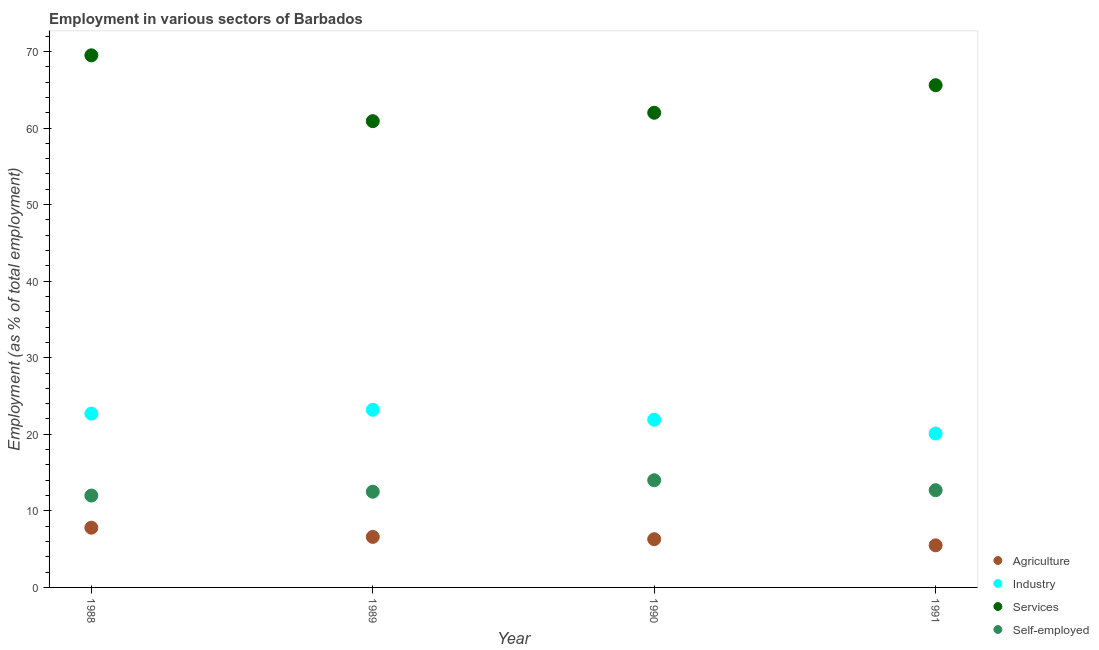How many different coloured dotlines are there?
Offer a very short reply. 4. What is the percentage of workers in services in 1991?
Make the answer very short. 65.6. Across all years, what is the maximum percentage of workers in industry?
Give a very brief answer. 23.2. Across all years, what is the minimum percentage of workers in services?
Make the answer very short. 60.9. In which year was the percentage of workers in industry maximum?
Your answer should be very brief. 1989. In which year was the percentage of self employed workers minimum?
Make the answer very short. 1988. What is the total percentage of workers in industry in the graph?
Give a very brief answer. 87.9. What is the difference between the percentage of workers in agriculture in 1990 and that in 1991?
Make the answer very short. 0.8. What is the difference between the percentage of self employed workers in 1988 and the percentage of workers in agriculture in 1990?
Your answer should be very brief. 5.7. What is the average percentage of workers in services per year?
Offer a very short reply. 64.5. In the year 1990, what is the difference between the percentage of workers in agriculture and percentage of self employed workers?
Your answer should be compact. -7.7. In how many years, is the percentage of self employed workers greater than 68 %?
Your answer should be very brief. 0. What is the ratio of the percentage of self employed workers in 1989 to that in 1990?
Keep it short and to the point. 0.89. Is the percentage of workers in agriculture in 1988 less than that in 1991?
Your answer should be very brief. No. Is the difference between the percentage of self employed workers in 1989 and 1990 greater than the difference between the percentage of workers in services in 1989 and 1990?
Your answer should be very brief. No. What is the difference between the highest and the second highest percentage of workers in agriculture?
Offer a terse response. 1.2. Is it the case that in every year, the sum of the percentage of workers in agriculture and percentage of workers in services is greater than the sum of percentage of workers in industry and percentage of self employed workers?
Provide a short and direct response. No. What is the difference between two consecutive major ticks on the Y-axis?
Provide a succinct answer. 10. Does the graph contain any zero values?
Ensure brevity in your answer.  No. Where does the legend appear in the graph?
Offer a terse response. Bottom right. How are the legend labels stacked?
Ensure brevity in your answer.  Vertical. What is the title of the graph?
Provide a succinct answer. Employment in various sectors of Barbados. What is the label or title of the Y-axis?
Your response must be concise. Employment (as % of total employment). What is the Employment (as % of total employment) in Agriculture in 1988?
Make the answer very short. 7.8. What is the Employment (as % of total employment) in Industry in 1988?
Make the answer very short. 22.7. What is the Employment (as % of total employment) of Services in 1988?
Provide a succinct answer. 69.5. What is the Employment (as % of total employment) in Self-employed in 1988?
Offer a terse response. 12. What is the Employment (as % of total employment) in Agriculture in 1989?
Keep it short and to the point. 6.6. What is the Employment (as % of total employment) in Industry in 1989?
Provide a short and direct response. 23.2. What is the Employment (as % of total employment) in Services in 1989?
Your answer should be compact. 60.9. What is the Employment (as % of total employment) in Agriculture in 1990?
Provide a short and direct response. 6.3. What is the Employment (as % of total employment) in Industry in 1990?
Your answer should be compact. 21.9. What is the Employment (as % of total employment) in Services in 1990?
Ensure brevity in your answer.  62. What is the Employment (as % of total employment) in Self-employed in 1990?
Your response must be concise. 14. What is the Employment (as % of total employment) in Agriculture in 1991?
Offer a very short reply. 5.5. What is the Employment (as % of total employment) of Industry in 1991?
Offer a very short reply. 20.1. What is the Employment (as % of total employment) in Services in 1991?
Ensure brevity in your answer.  65.6. What is the Employment (as % of total employment) of Self-employed in 1991?
Make the answer very short. 12.7. Across all years, what is the maximum Employment (as % of total employment) in Agriculture?
Your response must be concise. 7.8. Across all years, what is the maximum Employment (as % of total employment) in Industry?
Make the answer very short. 23.2. Across all years, what is the maximum Employment (as % of total employment) in Services?
Provide a short and direct response. 69.5. Across all years, what is the minimum Employment (as % of total employment) of Industry?
Your response must be concise. 20.1. Across all years, what is the minimum Employment (as % of total employment) of Services?
Provide a succinct answer. 60.9. What is the total Employment (as % of total employment) in Agriculture in the graph?
Make the answer very short. 26.2. What is the total Employment (as % of total employment) in Industry in the graph?
Keep it short and to the point. 87.9. What is the total Employment (as % of total employment) of Services in the graph?
Ensure brevity in your answer.  258. What is the total Employment (as % of total employment) of Self-employed in the graph?
Your answer should be compact. 51.2. What is the difference between the Employment (as % of total employment) of Industry in 1988 and that in 1989?
Ensure brevity in your answer.  -0.5. What is the difference between the Employment (as % of total employment) in Services in 1988 and that in 1989?
Give a very brief answer. 8.6. What is the difference between the Employment (as % of total employment) in Self-employed in 1988 and that in 1989?
Ensure brevity in your answer.  -0.5. What is the difference between the Employment (as % of total employment) of Agriculture in 1988 and that in 1990?
Your response must be concise. 1.5. What is the difference between the Employment (as % of total employment) of Industry in 1988 and that in 1990?
Provide a short and direct response. 0.8. What is the difference between the Employment (as % of total employment) in Agriculture in 1988 and that in 1991?
Offer a very short reply. 2.3. What is the difference between the Employment (as % of total employment) of Agriculture in 1989 and that in 1990?
Ensure brevity in your answer.  0.3. What is the difference between the Employment (as % of total employment) in Industry in 1989 and that in 1990?
Offer a very short reply. 1.3. What is the difference between the Employment (as % of total employment) of Services in 1989 and that in 1990?
Offer a terse response. -1.1. What is the difference between the Employment (as % of total employment) of Self-employed in 1989 and that in 1990?
Provide a short and direct response. -1.5. What is the difference between the Employment (as % of total employment) in Agriculture in 1989 and that in 1991?
Your answer should be compact. 1.1. What is the difference between the Employment (as % of total employment) of Self-employed in 1989 and that in 1991?
Provide a short and direct response. -0.2. What is the difference between the Employment (as % of total employment) in Industry in 1990 and that in 1991?
Keep it short and to the point. 1.8. What is the difference between the Employment (as % of total employment) of Self-employed in 1990 and that in 1991?
Your answer should be very brief. 1.3. What is the difference between the Employment (as % of total employment) in Agriculture in 1988 and the Employment (as % of total employment) in Industry in 1989?
Offer a very short reply. -15.4. What is the difference between the Employment (as % of total employment) of Agriculture in 1988 and the Employment (as % of total employment) of Services in 1989?
Provide a short and direct response. -53.1. What is the difference between the Employment (as % of total employment) in Industry in 1988 and the Employment (as % of total employment) in Services in 1989?
Offer a terse response. -38.2. What is the difference between the Employment (as % of total employment) in Industry in 1988 and the Employment (as % of total employment) in Self-employed in 1989?
Your response must be concise. 10.2. What is the difference between the Employment (as % of total employment) of Services in 1988 and the Employment (as % of total employment) of Self-employed in 1989?
Provide a short and direct response. 57. What is the difference between the Employment (as % of total employment) in Agriculture in 1988 and the Employment (as % of total employment) in Industry in 1990?
Offer a terse response. -14.1. What is the difference between the Employment (as % of total employment) in Agriculture in 1988 and the Employment (as % of total employment) in Services in 1990?
Provide a succinct answer. -54.2. What is the difference between the Employment (as % of total employment) in Industry in 1988 and the Employment (as % of total employment) in Services in 1990?
Provide a short and direct response. -39.3. What is the difference between the Employment (as % of total employment) of Industry in 1988 and the Employment (as % of total employment) of Self-employed in 1990?
Provide a short and direct response. 8.7. What is the difference between the Employment (as % of total employment) of Services in 1988 and the Employment (as % of total employment) of Self-employed in 1990?
Your answer should be very brief. 55.5. What is the difference between the Employment (as % of total employment) in Agriculture in 1988 and the Employment (as % of total employment) in Industry in 1991?
Offer a very short reply. -12.3. What is the difference between the Employment (as % of total employment) of Agriculture in 1988 and the Employment (as % of total employment) of Services in 1991?
Provide a succinct answer. -57.8. What is the difference between the Employment (as % of total employment) in Agriculture in 1988 and the Employment (as % of total employment) in Self-employed in 1991?
Offer a very short reply. -4.9. What is the difference between the Employment (as % of total employment) in Industry in 1988 and the Employment (as % of total employment) in Services in 1991?
Your answer should be compact. -42.9. What is the difference between the Employment (as % of total employment) in Industry in 1988 and the Employment (as % of total employment) in Self-employed in 1991?
Offer a terse response. 10. What is the difference between the Employment (as % of total employment) in Services in 1988 and the Employment (as % of total employment) in Self-employed in 1991?
Provide a succinct answer. 56.8. What is the difference between the Employment (as % of total employment) in Agriculture in 1989 and the Employment (as % of total employment) in Industry in 1990?
Make the answer very short. -15.3. What is the difference between the Employment (as % of total employment) in Agriculture in 1989 and the Employment (as % of total employment) in Services in 1990?
Offer a very short reply. -55.4. What is the difference between the Employment (as % of total employment) in Agriculture in 1989 and the Employment (as % of total employment) in Self-employed in 1990?
Your answer should be very brief. -7.4. What is the difference between the Employment (as % of total employment) of Industry in 1989 and the Employment (as % of total employment) of Services in 1990?
Your answer should be very brief. -38.8. What is the difference between the Employment (as % of total employment) in Industry in 1989 and the Employment (as % of total employment) in Self-employed in 1990?
Make the answer very short. 9.2. What is the difference between the Employment (as % of total employment) of Services in 1989 and the Employment (as % of total employment) of Self-employed in 1990?
Offer a very short reply. 46.9. What is the difference between the Employment (as % of total employment) in Agriculture in 1989 and the Employment (as % of total employment) in Services in 1991?
Give a very brief answer. -59. What is the difference between the Employment (as % of total employment) in Agriculture in 1989 and the Employment (as % of total employment) in Self-employed in 1991?
Your answer should be very brief. -6.1. What is the difference between the Employment (as % of total employment) in Industry in 1989 and the Employment (as % of total employment) in Services in 1991?
Your answer should be very brief. -42.4. What is the difference between the Employment (as % of total employment) in Industry in 1989 and the Employment (as % of total employment) in Self-employed in 1991?
Ensure brevity in your answer.  10.5. What is the difference between the Employment (as % of total employment) in Services in 1989 and the Employment (as % of total employment) in Self-employed in 1991?
Offer a very short reply. 48.2. What is the difference between the Employment (as % of total employment) in Agriculture in 1990 and the Employment (as % of total employment) in Industry in 1991?
Provide a short and direct response. -13.8. What is the difference between the Employment (as % of total employment) of Agriculture in 1990 and the Employment (as % of total employment) of Services in 1991?
Make the answer very short. -59.3. What is the difference between the Employment (as % of total employment) of Agriculture in 1990 and the Employment (as % of total employment) of Self-employed in 1991?
Give a very brief answer. -6.4. What is the difference between the Employment (as % of total employment) of Industry in 1990 and the Employment (as % of total employment) of Services in 1991?
Your response must be concise. -43.7. What is the difference between the Employment (as % of total employment) in Services in 1990 and the Employment (as % of total employment) in Self-employed in 1991?
Offer a very short reply. 49.3. What is the average Employment (as % of total employment) of Agriculture per year?
Offer a very short reply. 6.55. What is the average Employment (as % of total employment) in Industry per year?
Make the answer very short. 21.98. What is the average Employment (as % of total employment) in Services per year?
Offer a very short reply. 64.5. In the year 1988, what is the difference between the Employment (as % of total employment) of Agriculture and Employment (as % of total employment) of Industry?
Your response must be concise. -14.9. In the year 1988, what is the difference between the Employment (as % of total employment) in Agriculture and Employment (as % of total employment) in Services?
Your response must be concise. -61.7. In the year 1988, what is the difference between the Employment (as % of total employment) in Agriculture and Employment (as % of total employment) in Self-employed?
Provide a succinct answer. -4.2. In the year 1988, what is the difference between the Employment (as % of total employment) of Industry and Employment (as % of total employment) of Services?
Offer a terse response. -46.8. In the year 1988, what is the difference between the Employment (as % of total employment) of Services and Employment (as % of total employment) of Self-employed?
Make the answer very short. 57.5. In the year 1989, what is the difference between the Employment (as % of total employment) in Agriculture and Employment (as % of total employment) in Industry?
Offer a terse response. -16.6. In the year 1989, what is the difference between the Employment (as % of total employment) of Agriculture and Employment (as % of total employment) of Services?
Provide a short and direct response. -54.3. In the year 1989, what is the difference between the Employment (as % of total employment) of Agriculture and Employment (as % of total employment) of Self-employed?
Offer a terse response. -5.9. In the year 1989, what is the difference between the Employment (as % of total employment) in Industry and Employment (as % of total employment) in Services?
Provide a succinct answer. -37.7. In the year 1989, what is the difference between the Employment (as % of total employment) in Services and Employment (as % of total employment) in Self-employed?
Your response must be concise. 48.4. In the year 1990, what is the difference between the Employment (as % of total employment) in Agriculture and Employment (as % of total employment) in Industry?
Offer a very short reply. -15.6. In the year 1990, what is the difference between the Employment (as % of total employment) of Agriculture and Employment (as % of total employment) of Services?
Ensure brevity in your answer.  -55.7. In the year 1990, what is the difference between the Employment (as % of total employment) of Industry and Employment (as % of total employment) of Services?
Your answer should be compact. -40.1. In the year 1991, what is the difference between the Employment (as % of total employment) of Agriculture and Employment (as % of total employment) of Industry?
Your answer should be compact. -14.6. In the year 1991, what is the difference between the Employment (as % of total employment) in Agriculture and Employment (as % of total employment) in Services?
Make the answer very short. -60.1. In the year 1991, what is the difference between the Employment (as % of total employment) of Agriculture and Employment (as % of total employment) of Self-employed?
Make the answer very short. -7.2. In the year 1991, what is the difference between the Employment (as % of total employment) in Industry and Employment (as % of total employment) in Services?
Ensure brevity in your answer.  -45.5. In the year 1991, what is the difference between the Employment (as % of total employment) of Industry and Employment (as % of total employment) of Self-employed?
Your answer should be compact. 7.4. In the year 1991, what is the difference between the Employment (as % of total employment) of Services and Employment (as % of total employment) of Self-employed?
Offer a terse response. 52.9. What is the ratio of the Employment (as % of total employment) in Agriculture in 1988 to that in 1989?
Your answer should be very brief. 1.18. What is the ratio of the Employment (as % of total employment) of Industry in 1988 to that in 1989?
Offer a very short reply. 0.98. What is the ratio of the Employment (as % of total employment) of Services in 1988 to that in 1989?
Make the answer very short. 1.14. What is the ratio of the Employment (as % of total employment) in Agriculture in 1988 to that in 1990?
Your answer should be compact. 1.24. What is the ratio of the Employment (as % of total employment) in Industry in 1988 to that in 1990?
Your answer should be very brief. 1.04. What is the ratio of the Employment (as % of total employment) of Services in 1988 to that in 1990?
Give a very brief answer. 1.12. What is the ratio of the Employment (as % of total employment) of Agriculture in 1988 to that in 1991?
Offer a terse response. 1.42. What is the ratio of the Employment (as % of total employment) in Industry in 1988 to that in 1991?
Make the answer very short. 1.13. What is the ratio of the Employment (as % of total employment) of Services in 1988 to that in 1991?
Your response must be concise. 1.06. What is the ratio of the Employment (as % of total employment) in Self-employed in 1988 to that in 1991?
Make the answer very short. 0.94. What is the ratio of the Employment (as % of total employment) of Agriculture in 1989 to that in 1990?
Give a very brief answer. 1.05. What is the ratio of the Employment (as % of total employment) of Industry in 1989 to that in 1990?
Your answer should be very brief. 1.06. What is the ratio of the Employment (as % of total employment) in Services in 1989 to that in 1990?
Your response must be concise. 0.98. What is the ratio of the Employment (as % of total employment) of Self-employed in 1989 to that in 1990?
Your answer should be compact. 0.89. What is the ratio of the Employment (as % of total employment) in Agriculture in 1989 to that in 1991?
Provide a succinct answer. 1.2. What is the ratio of the Employment (as % of total employment) in Industry in 1989 to that in 1991?
Give a very brief answer. 1.15. What is the ratio of the Employment (as % of total employment) of Services in 1989 to that in 1991?
Keep it short and to the point. 0.93. What is the ratio of the Employment (as % of total employment) of Self-employed in 1989 to that in 1991?
Provide a short and direct response. 0.98. What is the ratio of the Employment (as % of total employment) of Agriculture in 1990 to that in 1991?
Offer a very short reply. 1.15. What is the ratio of the Employment (as % of total employment) of Industry in 1990 to that in 1991?
Offer a terse response. 1.09. What is the ratio of the Employment (as % of total employment) in Services in 1990 to that in 1991?
Your answer should be compact. 0.95. What is the ratio of the Employment (as % of total employment) of Self-employed in 1990 to that in 1991?
Keep it short and to the point. 1.1. What is the difference between the highest and the second highest Employment (as % of total employment) in Agriculture?
Offer a terse response. 1.2. What is the difference between the highest and the second highest Employment (as % of total employment) in Industry?
Provide a short and direct response. 0.5. What is the difference between the highest and the second highest Employment (as % of total employment) in Services?
Provide a succinct answer. 3.9. What is the difference between the highest and the lowest Employment (as % of total employment) of Agriculture?
Provide a short and direct response. 2.3. What is the difference between the highest and the lowest Employment (as % of total employment) in Industry?
Offer a terse response. 3.1. What is the difference between the highest and the lowest Employment (as % of total employment) of Self-employed?
Provide a succinct answer. 2. 